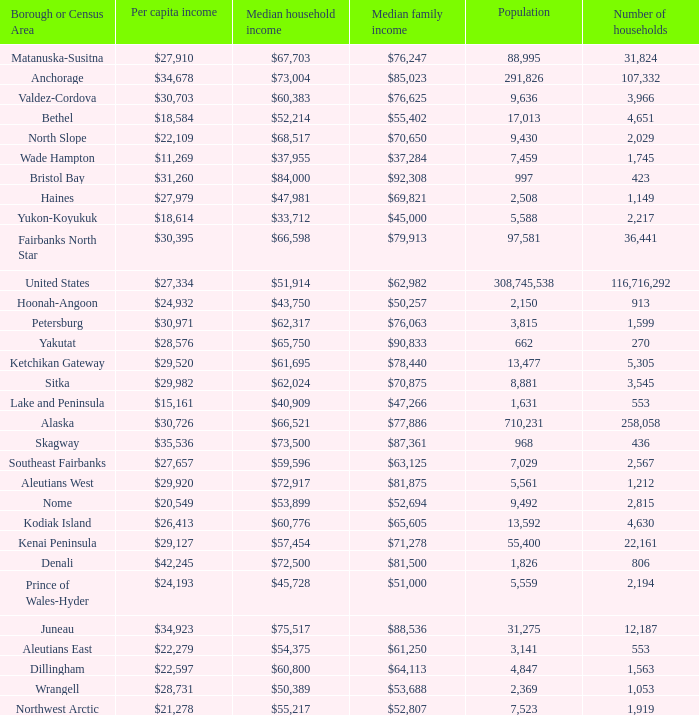Which borough or census area has a $59,596 median household income? Southeast Fairbanks. 